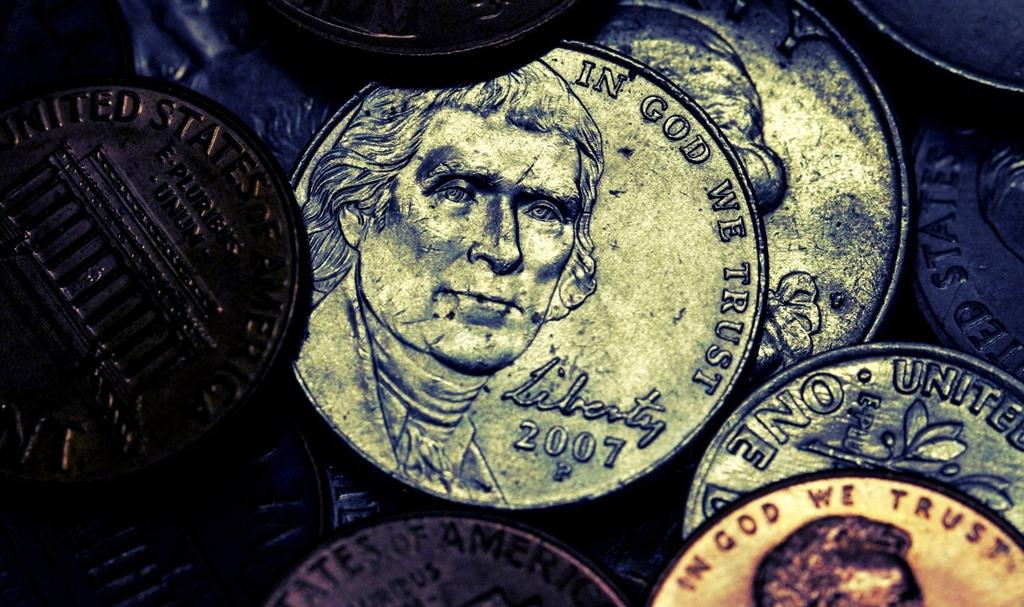What year is listed on the nickel?
Keep it short and to the point. 2007. What is the slogan on the top of the coin in the middle?
Make the answer very short. In god we trust. 